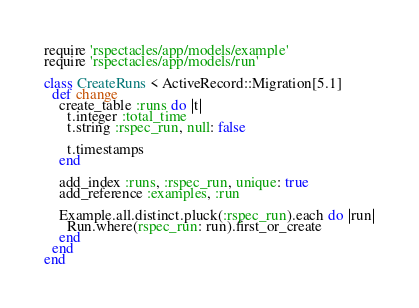Convert code to text. <code><loc_0><loc_0><loc_500><loc_500><_Ruby_>require 'rspectacles/app/models/example'
require 'rspectacles/app/models/run'

class CreateRuns < ActiveRecord::Migration[5.1]
  def change
    create_table :runs do |t|
      t.integer :total_time
      t.string :rspec_run, null: false

      t.timestamps
    end

    add_index :runs, :rspec_run, unique: true
    add_reference :examples, :run

    Example.all.distinct.pluck(:rspec_run).each do |run|
      Run.where(rspec_run: run).first_or_create
    end
  end
end
</code> 